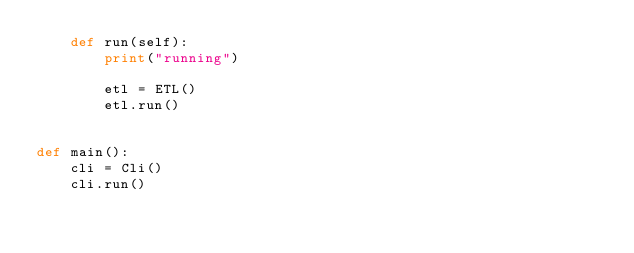Convert code to text. <code><loc_0><loc_0><loc_500><loc_500><_Python_>    def run(self):
        print("running")

        etl = ETL()
        etl.run()


def main():
    cli = Cli()
    cli.run()
</code> 